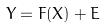Convert formula to latex. <formula><loc_0><loc_0><loc_500><loc_500>Y = F ( X ) + E</formula> 